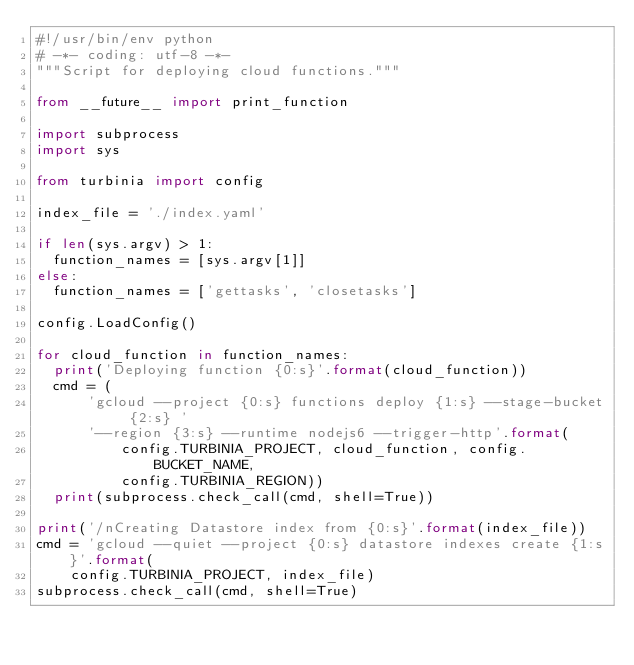<code> <loc_0><loc_0><loc_500><loc_500><_Python_>#!/usr/bin/env python
# -*- coding: utf-8 -*-
"""Script for deploying cloud functions."""

from __future__ import print_function

import subprocess
import sys

from turbinia import config

index_file = './index.yaml'

if len(sys.argv) > 1:
  function_names = [sys.argv[1]]
else:
  function_names = ['gettasks', 'closetasks']

config.LoadConfig()

for cloud_function in function_names:
  print('Deploying function {0:s}'.format(cloud_function))
  cmd = (
      'gcloud --project {0:s} functions deploy {1:s} --stage-bucket {2:s} '
      '--region {3:s} --runtime nodejs6 --trigger-http'.format(
          config.TURBINIA_PROJECT, cloud_function, config.BUCKET_NAME,
          config.TURBINIA_REGION))
  print(subprocess.check_call(cmd, shell=True))

print('/nCreating Datastore index from {0:s}'.format(index_file))
cmd = 'gcloud --quiet --project {0:s} datastore indexes create {1:s}'.format(
    config.TURBINIA_PROJECT, index_file)
subprocess.check_call(cmd, shell=True)
</code> 